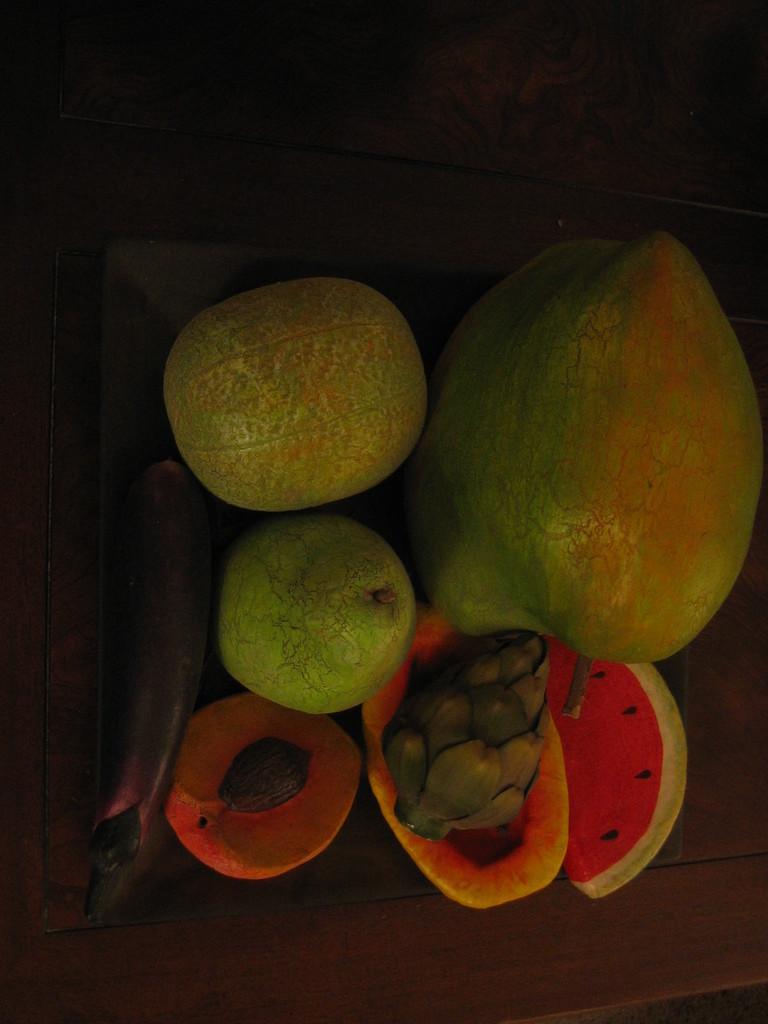Could you give a brief overview of what you see in this image? In this image I can see few fruits, they are in red, orange, brown and green color and I can see dark background. 